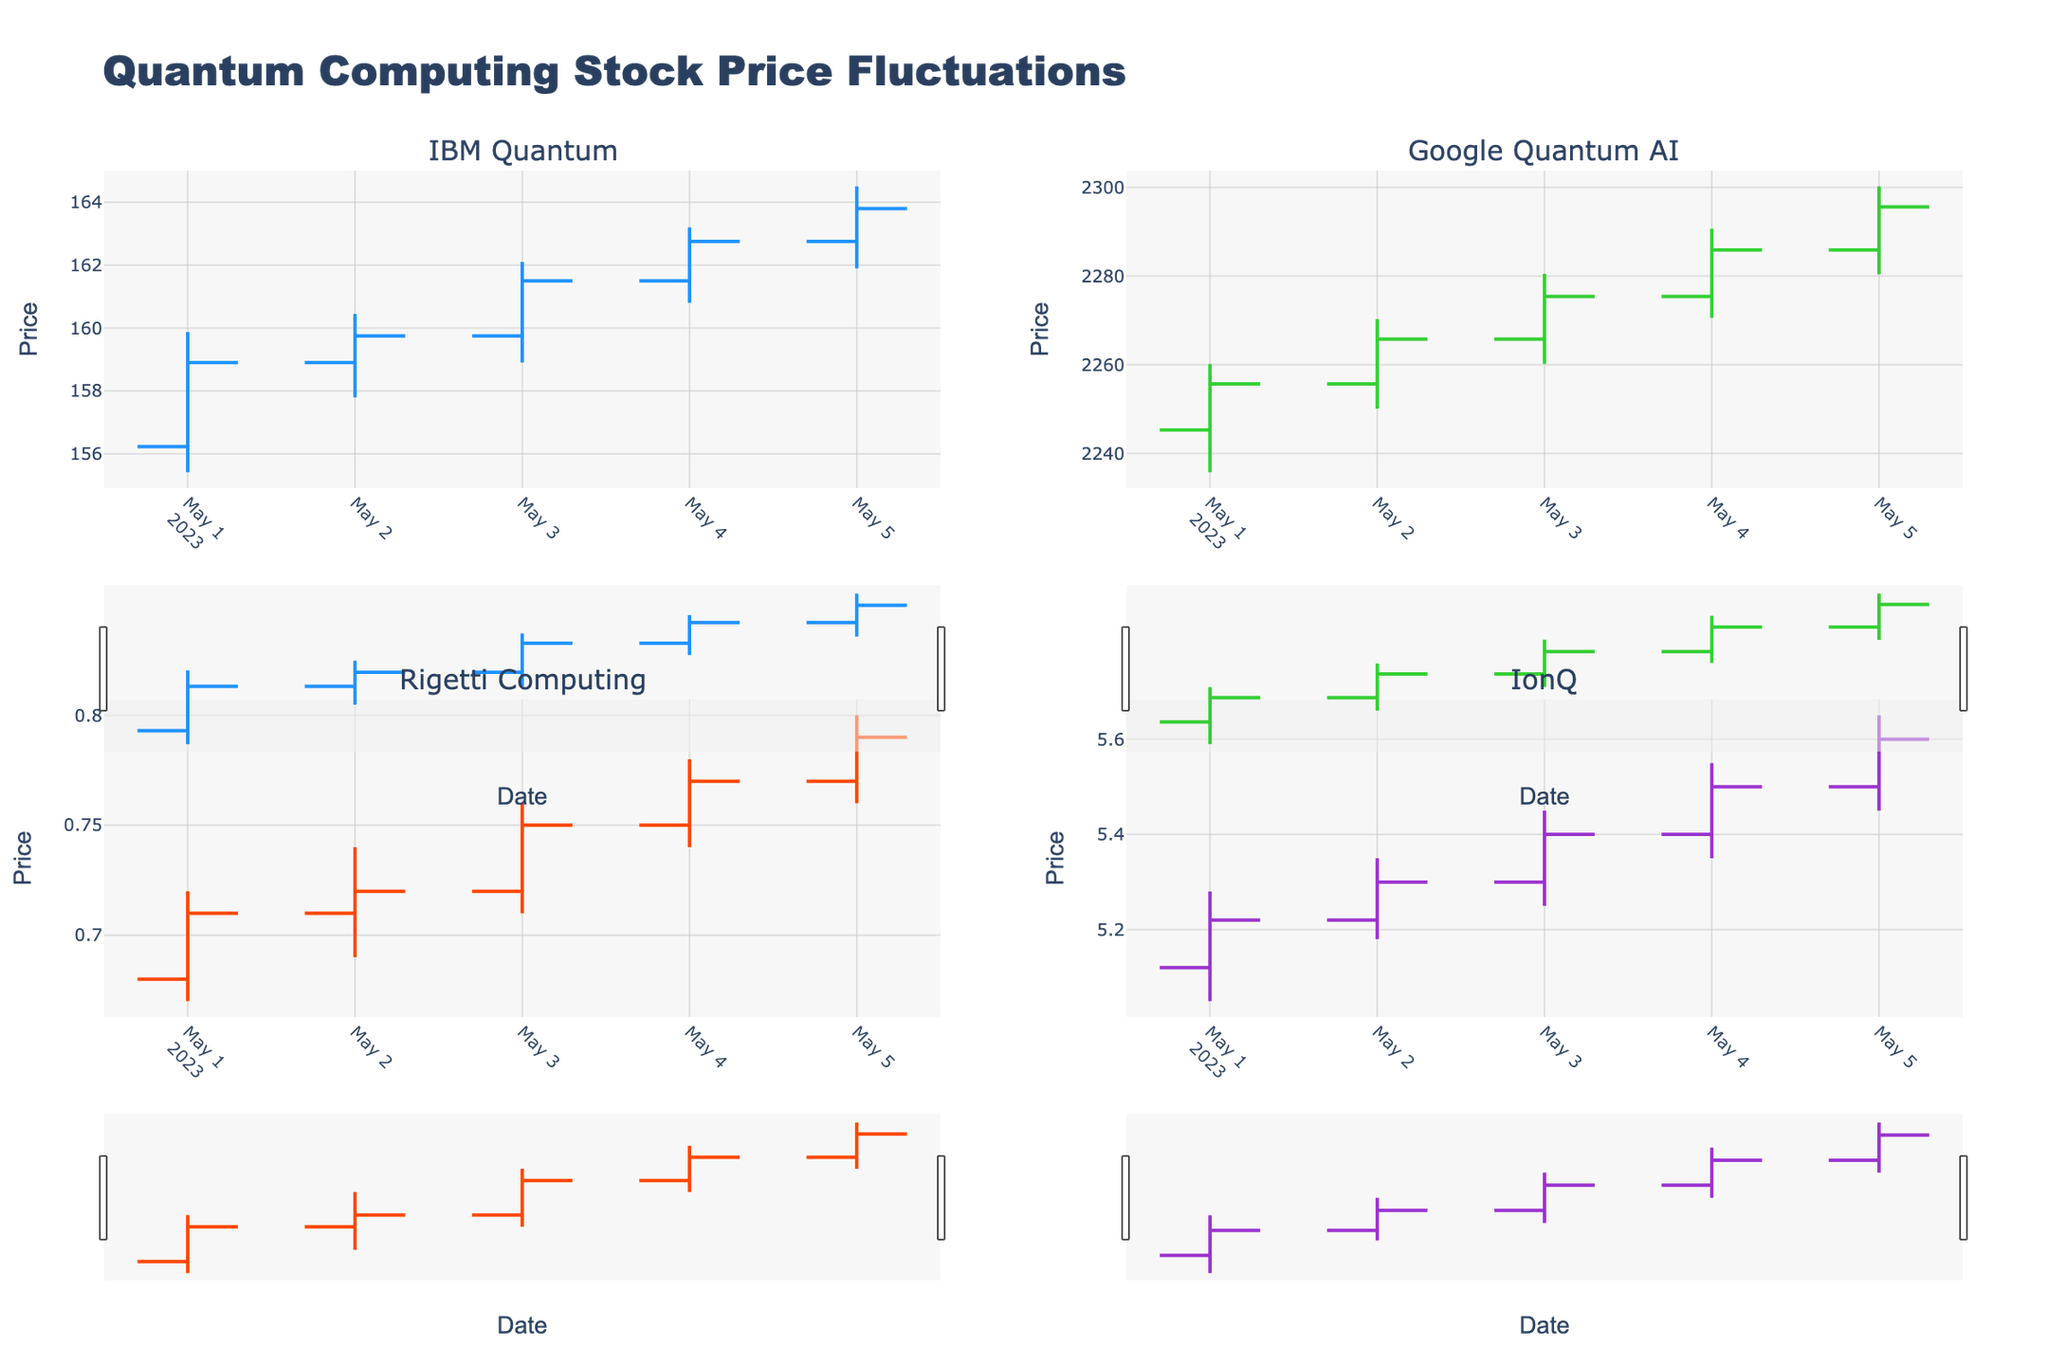What is the title of the figure? The title of the figure is located at the top and it clearly specifies what the chart represents.
Answer: Quantum Computing Stock Price Fluctuations How many companies' stock prices are illustrated in the figure? The figure has four distinct subplots, each labeled with a different company name.
Answer: Four Which company shows the highest closing price on May 3, 2023? Look at the subplots and find the highest closing price on the specific date. Google Quantum AI has the highest closing price on that date: 2275.40.
Answer: Google Quantum AI What color is used to represent IBM Quantum's increasing values? Identify the color of the bars in IBM Quantum's subplot that signify an increase. They're blue.
Answer: Blue Which company had the largest increase in closing price between May 1, 2023, and May 5, 2023? Subtract the closing price on May 1 from the closing price on May 5 for each company and compare: IBM Quantum (163.80-158.90=4.90), Google Quantum AI (2295.60-2255.70=39.90), Rigetti Computing (0.79-0.71=0.08), IonQ (5.60-5.22=0.38). Google Quantum AI has the highest increase.
Answer: Google Quantum AI Which subplot displays the daily lowest stock price of 0.67? Look at the 'Low' values across all subplots. The Rigetti Computing subplot shows a low of 0.67 on May 1.
Answer: Rigetti Computing What is the average opening price for IonQ from May 1 to May 5, 2023? Sum up the opening prices for IonQ (5.12 + 5.22 + 5.30 + 5.40 + 5.50 = 26.54) and divide by the number of days (5).
Answer: 5.31 Which company's stock price displayed an increase in closing values for each consecutive day from May 1 to May 5, 2023? Check each subplot to find a company whose closing prices increase every day in the given range. IBM Quantum's closing prices consistently increase over each day (158.90, 159.75, 161.50, 162.75, 163.80).
Answer: IBM Quantum What is the difference between the highest and lowest price of Rigetti Computing on May 2, 2023? Subtract the lowest price (0.69) from the highest price (0.74) for Rigetti Computing on that date: 0.74 - 0.69 = 0.05
Answer: 0.05 Which company had the highest volatility (difference between high and low prices) on May 1, 2023? Calculate the high-low difference for each company on May 1: IBM Quantum (159.87-155.42=4.45), Google Quantum AI (2260.15-2235.80=24.35), Rigetti Computing (0.72-0.67=0.05), IonQ (5.28-5.05=0.23). Google Quantum AI has the highest volatility.
Answer: Google Quantum AI 